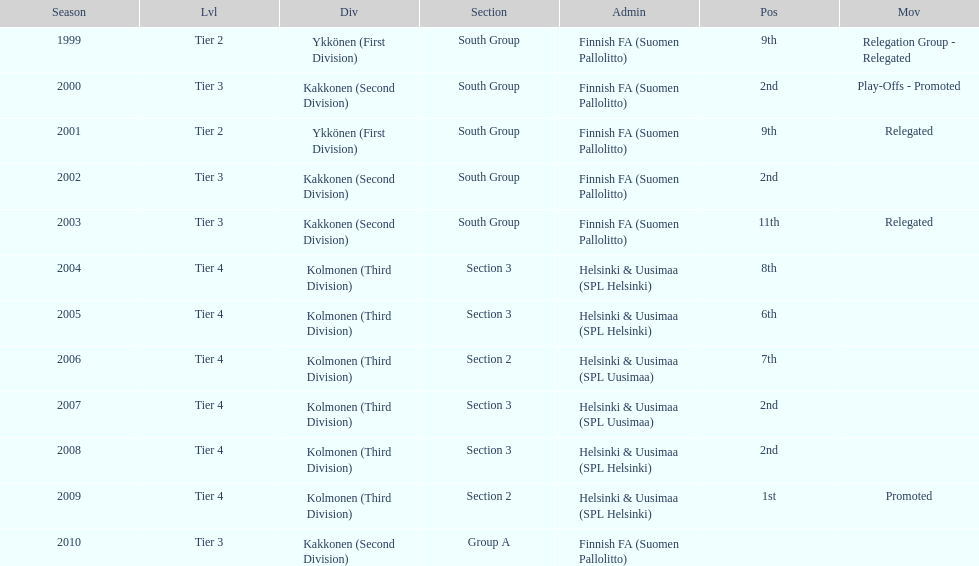What is the first tier listed? Tier 2. 